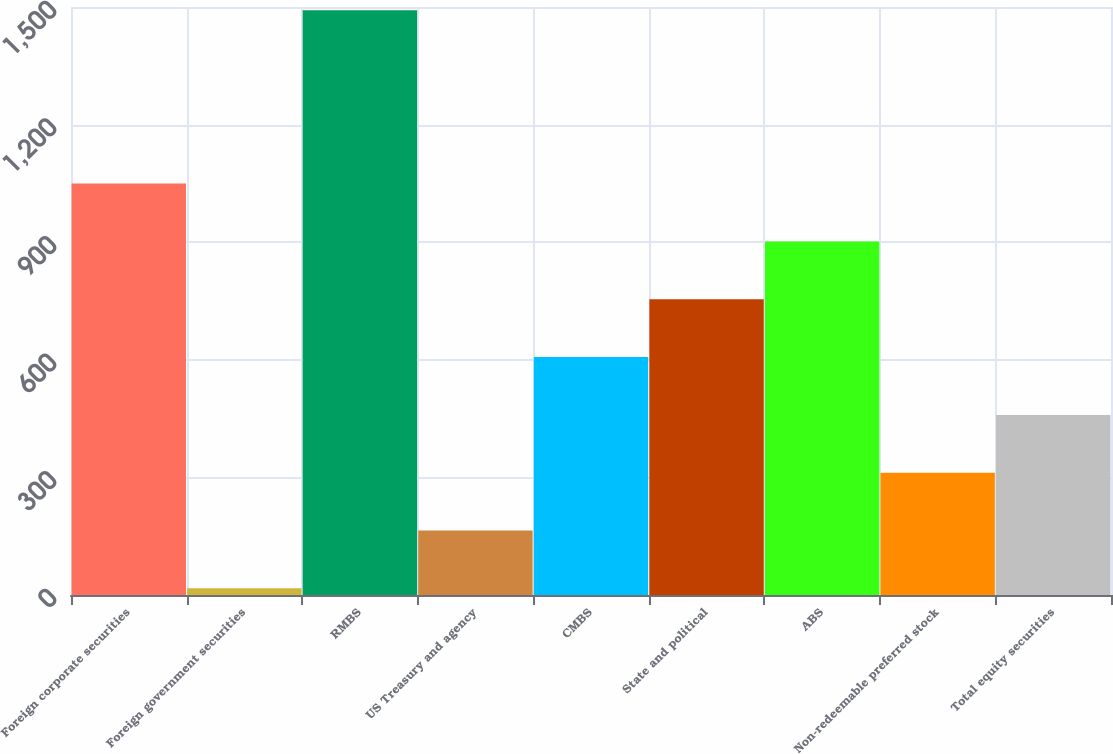Convert chart to OTSL. <chart><loc_0><loc_0><loc_500><loc_500><bar_chart><fcel>Foreign corporate securities<fcel>Foreign government securities<fcel>RMBS<fcel>US Treasury and agency<fcel>CMBS<fcel>State and political<fcel>ABS<fcel>Non-redeemable preferred stock<fcel>Total equity securities<nl><fcel>1049.5<fcel>17<fcel>1492<fcel>164.5<fcel>607<fcel>754.5<fcel>902<fcel>312<fcel>459.5<nl></chart> 